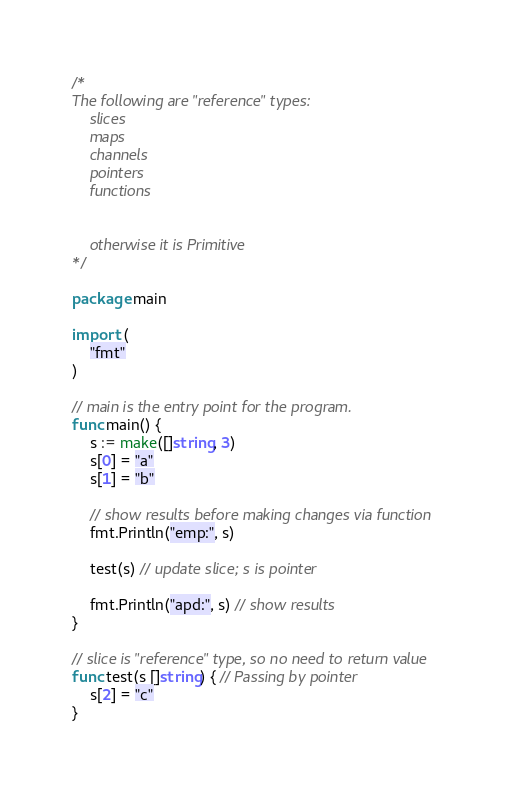<code> <loc_0><loc_0><loc_500><loc_500><_Go_>/*
The following are "reference" types:
	slices
	maps
	channels
	pointers
	functions


	otherwise it is Primitive
*/

package main

import (
	"fmt"
)

// main is the entry point for the program.
func main() {
	s := make([]string, 3)
	s[0] = "a"
	s[1] = "b"

	// show results before making changes via function
	fmt.Println("emp:", s)

	test(s) // update slice; s is pointer

	fmt.Println("apd:", s) // show results
}

// slice is "reference" type, so no need to return value
func test(s []string) { // Passing by pointer
	s[2] = "c"
}
</code> 